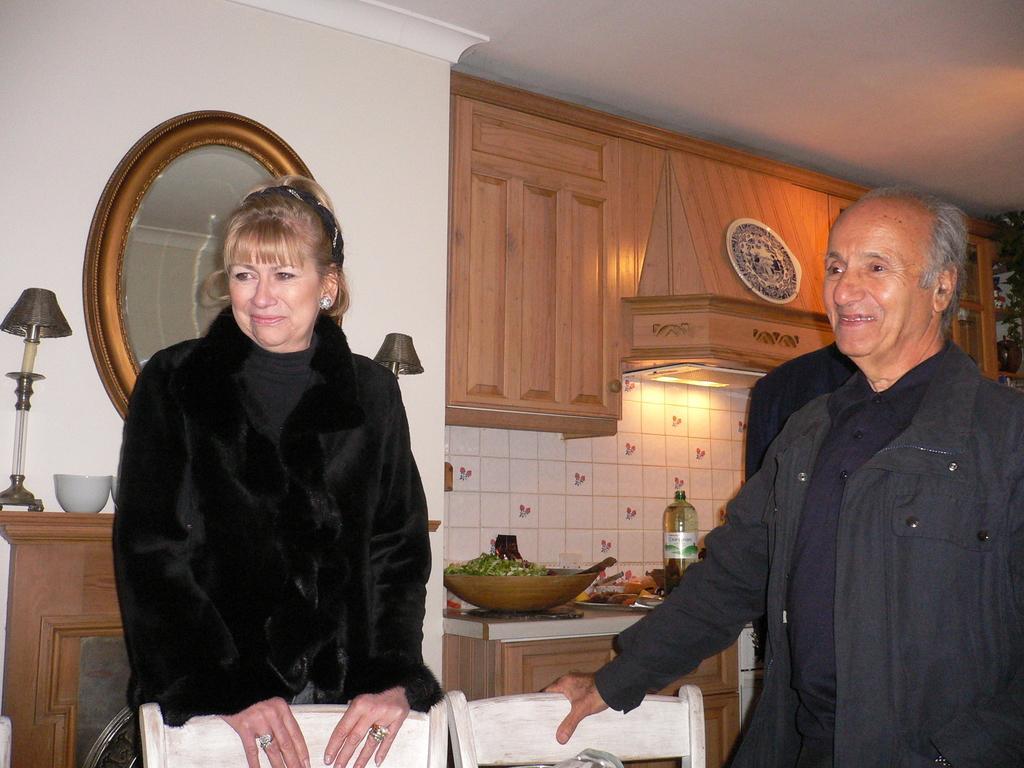Please provide a concise description of this image. In the image we can see a man and a woman are standing, they are wearing clothes, This is a fingering, earring and hair belt. There is a bottle, basket, lamp, bowl, light, cupboard, mirror and chair. The man and woman are smiling. 